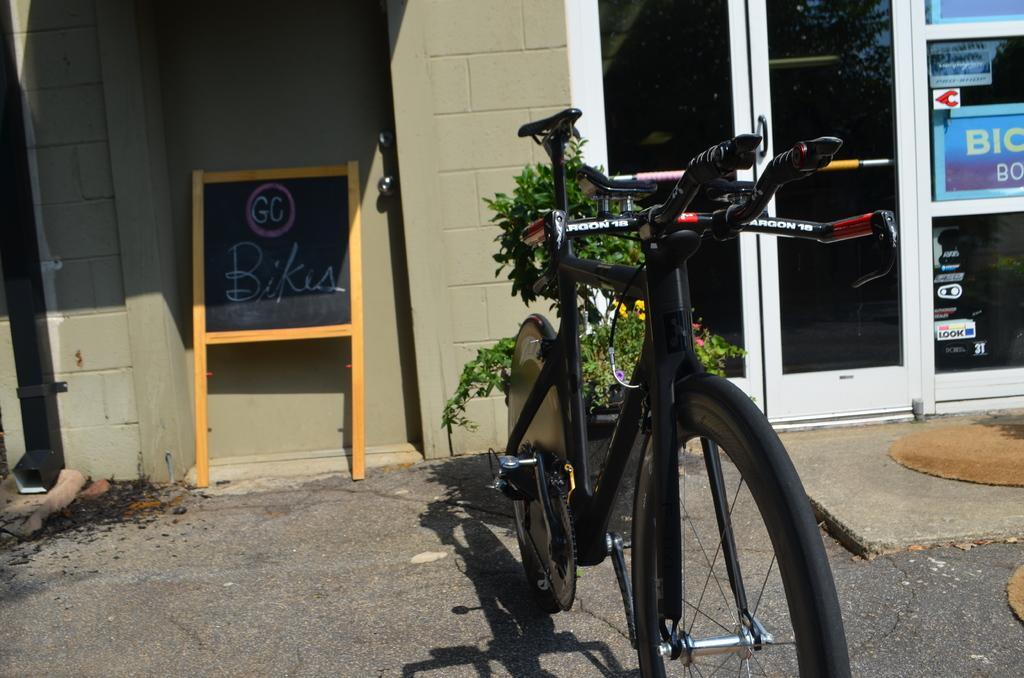How would you summarize this image in a sentence or two? In this image, in the middle there is a flower pot, in which there is a plant, board, wall, door, on which there are some posters attached, in the foreground there is a bicycle kept on the road. 